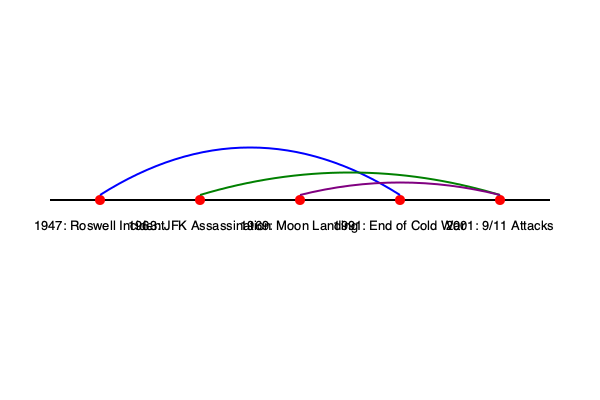Based on the timeline and interconnected events shown in the graphic, which conspiracy theory is most likely to link the Moon Landing (1969) with the 9/11 Attacks (2001)? To answer this question, we need to analyze the connections shown in the timeline:

1. The blue arc connects the Roswell Incident (1947) to the End of Cold War (1991). This suggests a long-term conspiracy theory involving extraterrestrial influence on geopolitics.

2. The green arc connects the JFK Assassination (1963) to the 9/11 Attacks (2001). This implies a potential conspiracy theory linking these two major U.S. events, possibly involving government cover-ups or hidden agendas.

3. The purple arc directly connects the Moon Landing (1969) to the 9/11 Attacks (2001). This is the connection we're looking for in the question.

4. Given the nature of these events, a common conspiracy theory that could link the Moon Landing and 9/11 Attacks is the idea of a "False Flag Operation."

5. The "False Flag Operation" theory suggests that significant events are staged or manipulated by governments or powerful groups to achieve specific goals, such as influencing public opinion or justifying certain actions.

6. In this context, conspiracy theorists might argue that both the Moon Landing and 9/11 Attacks were fabricated or orchestrated events designed to distract the public, justify government actions, or advance hidden agendas.

Therefore, the most likely conspiracy theory linking these two events would be the concept of "False Flag Operations" or staged events for political or social manipulation.
Answer: False Flag Operations 